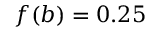<formula> <loc_0><loc_0><loc_500><loc_500>f ( b ) = 0 . 2 5</formula> 